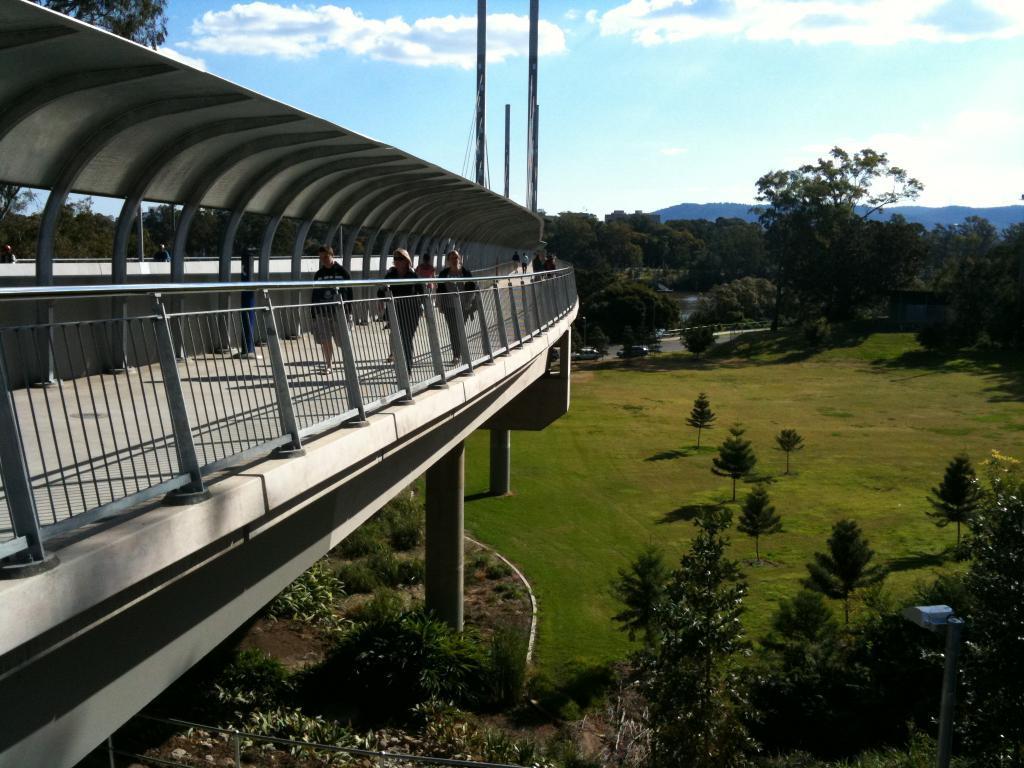In one or two sentences, can you explain what this image depicts? In this image, we can see so many trees, bridge, planted, grass, pillars, poles. Background there is a sky. Here we can see few people are walking through the walkway. 